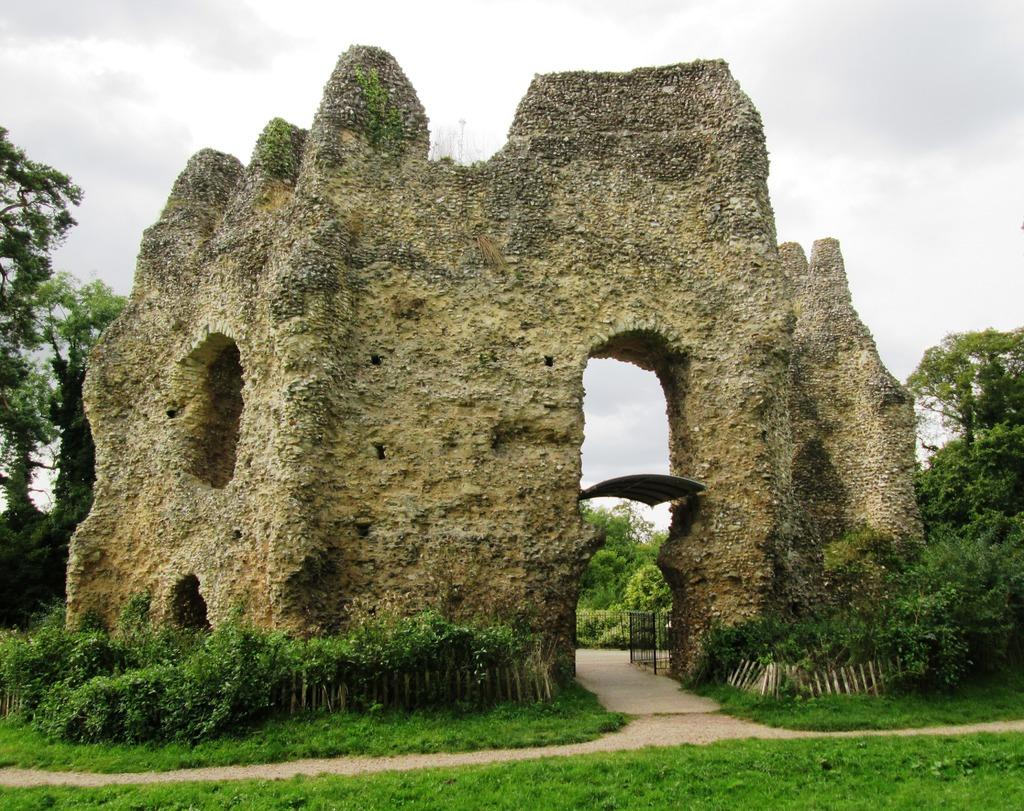What is the main structure in the center of the image? There is a wall in the center of the image. What feature can be seen on the wall? There is an arch on the wall. What type of vegetation is present at the bottom of the image? There is grass at the bottom of the image. What type of barrier is visible in the image? There is a fence visible in the image. What can be seen in the background of the image? There are trees and the sky visible in the background of the image. What type of reward is being given to the band in the image? There is no band or reward present in the image. 